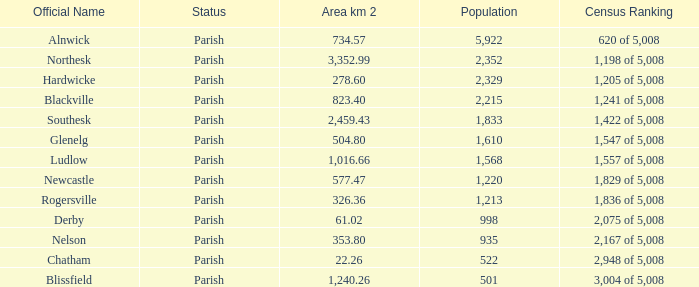Can you tell me the lowest Area km 2 that has the Population of 2,352? 3352.99. 